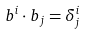Convert formula to latex. <formula><loc_0><loc_0><loc_500><loc_500>b ^ { i } \cdot b _ { j } = \delta _ { j } ^ { i }</formula> 